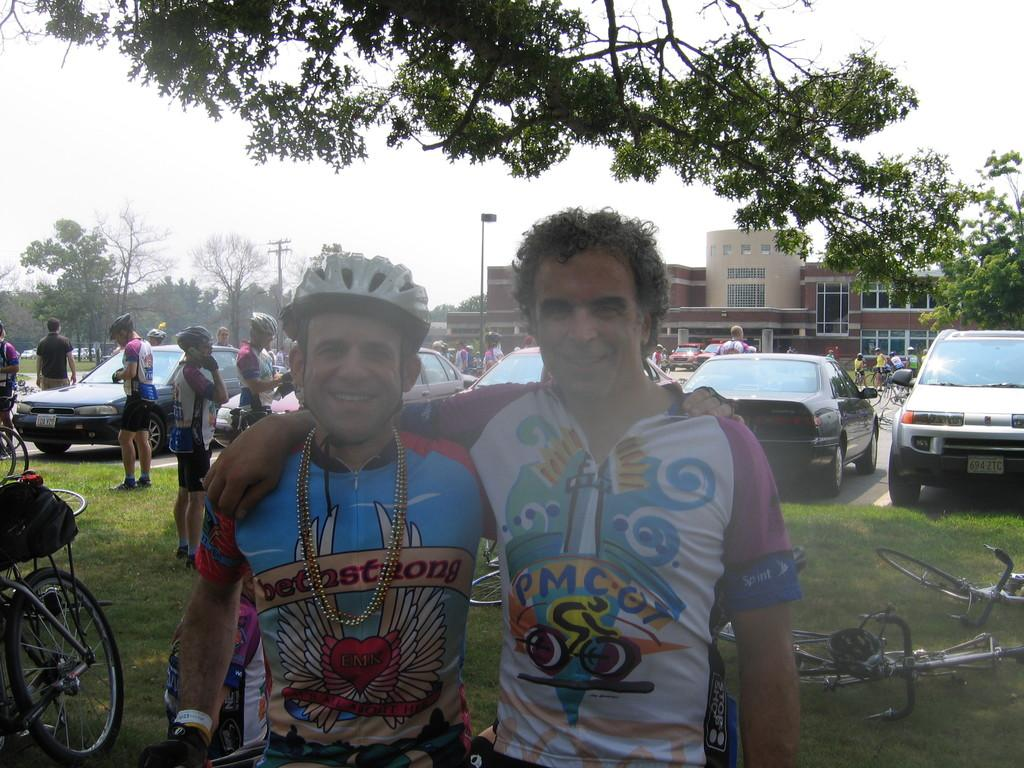How many men are in the image? There are two men in the image. What are the men doing in the image? The men are standing and smiling. Can you describe the background of the image? There are people, vehicles, a building, and a tree in the background of the image. What type of work is the boy doing in the image? There is no boy present in the image, so it is not possible to answer that question. 